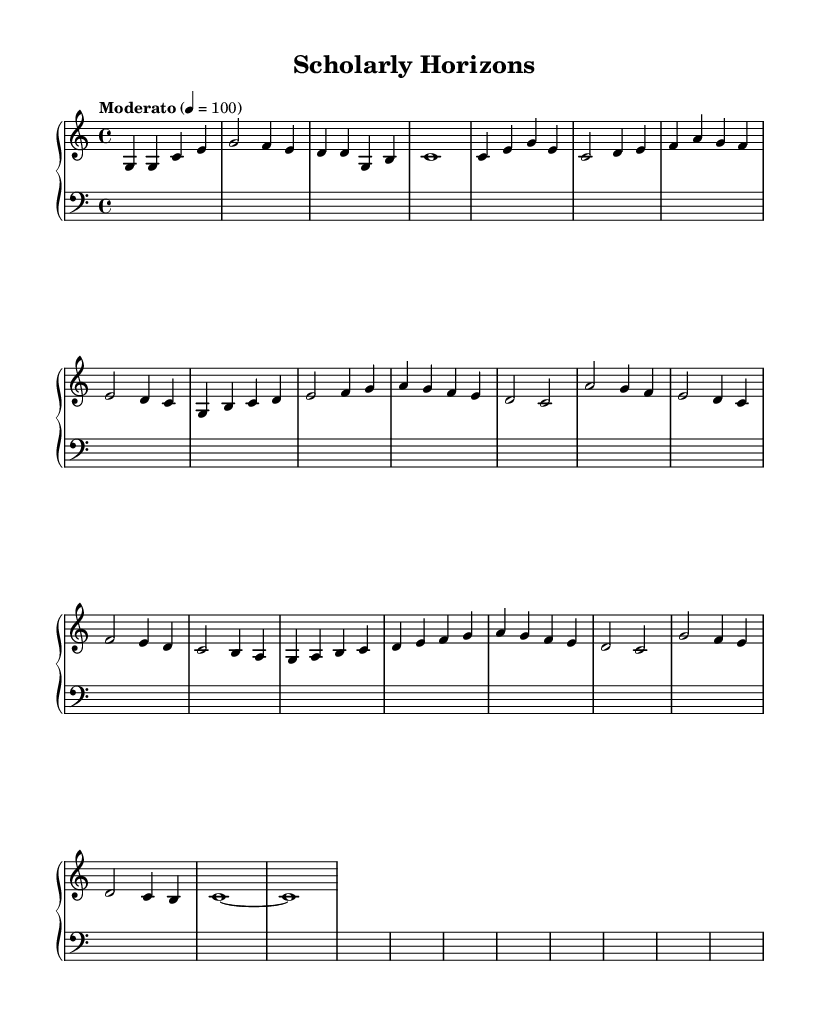What is the time signature of this music? The time signature is indicated at the beginning of the score, represented as "4/4". This means there are four beats in each measure and the quarter note gets one beat.
Answer: 4/4 What is the tempo marking for this piece? The tempo marking is given in the score as "Moderato" with a metronome marking of "4 = 100". This indicates a moderate pace, specifically at 100 beats per minute.
Answer: Moderato 4 = 100 How many measures are in this sheet music? By counting each set of vertical lines that separate the groups of notes, we find there are 16 measures total in this score.
Answer: 16 What is the highest note in the piece? The highest note can be found by looking at the notes on the staff, which is the B in the fifth octave (B' or B above the staff).
Answer: B What chord do the first four notes form? The first four notes are G, G, C, and E. When played together, these notes form a C major chord in root position (C, E, G).
Answer: C major How does the second half of the piece contrast with the first half? The second half introduces a downward progression in melody and features a more subdued dynamic in comparison to the rising phrases in the first half, creating a contrasting effect.
Answer: Contrast in dynamics 